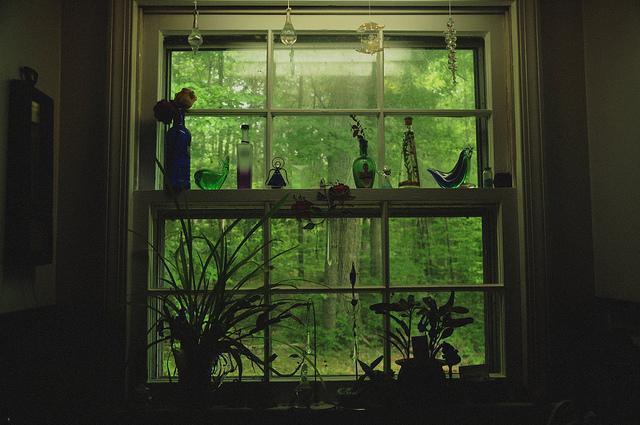How many houseplants are there?
Give a very brief answer. 2. How many panes of. glass were used for. the windows?
Give a very brief answer. 12. How many potted plants can you see?
Give a very brief answer. 2. How many people are there with facial hair?
Give a very brief answer. 0. 